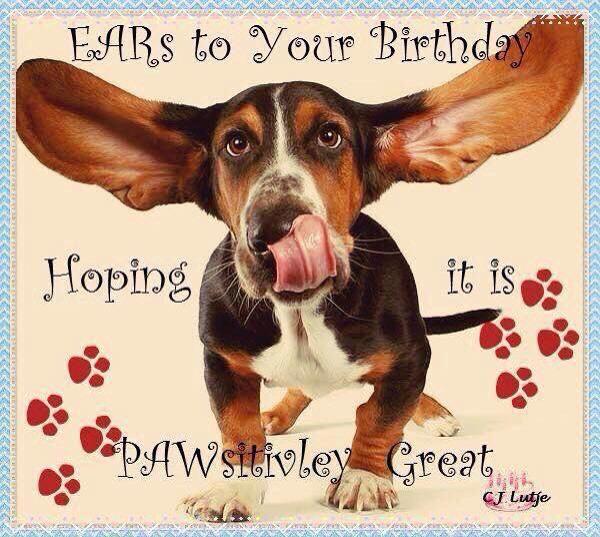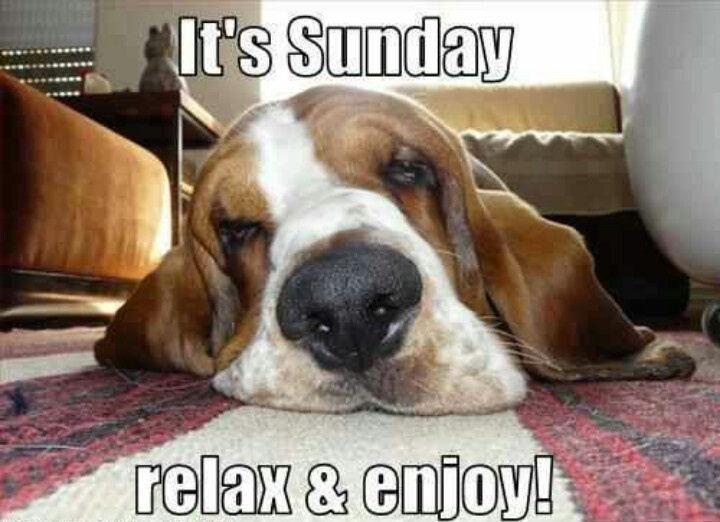The first image is the image on the left, the second image is the image on the right. Considering the images on both sides, is "The dog in at least one of the images is outside." valid? Answer yes or no. No. The first image is the image on the left, the second image is the image on the right. Considering the images on both sides, is "One of the dogs is wearing a birthday hat." valid? Answer yes or no. No. 